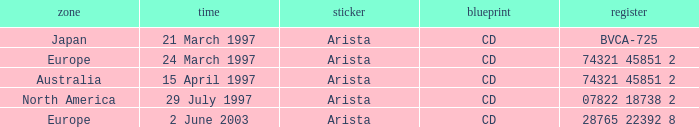What Date has the Region Europe and a Catalog of 74321 45851 2? 24 March 1997. 